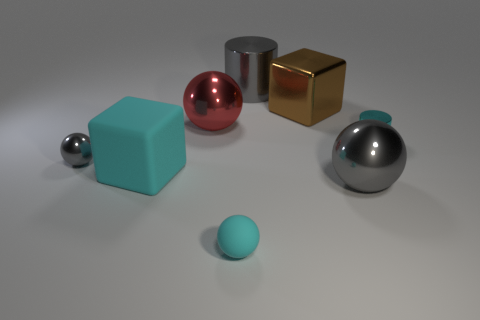Is there anything else of the same color as the metal block?
Provide a short and direct response. No. What color is the metal cylinder on the left side of the tiny thing on the right side of the big gray thing that is behind the tiny gray sphere?
Provide a short and direct response. Gray. What is the size of the gray metallic ball right of the rubber block to the left of the big gray cylinder?
Give a very brief answer. Large. There is a small object that is in front of the small cyan metal cylinder and right of the cyan matte cube; what material is it?
Provide a short and direct response. Rubber. There is a gray metal cylinder; is it the same size as the gray metal thing that is in front of the small gray sphere?
Offer a terse response. Yes. Are any big blue matte blocks visible?
Ensure brevity in your answer.  No. There is a large object that is the same shape as the small cyan shiny thing; what is its material?
Offer a terse response. Metal. There is a cyan thing behind the cyan object that is on the left side of the cyan sphere in front of the large cyan cube; what is its size?
Your answer should be very brief. Small. There is a cyan cylinder; are there any tiny objects in front of it?
Offer a terse response. Yes. There is a cyan sphere that is the same material as the big cyan thing; what size is it?
Ensure brevity in your answer.  Small. 